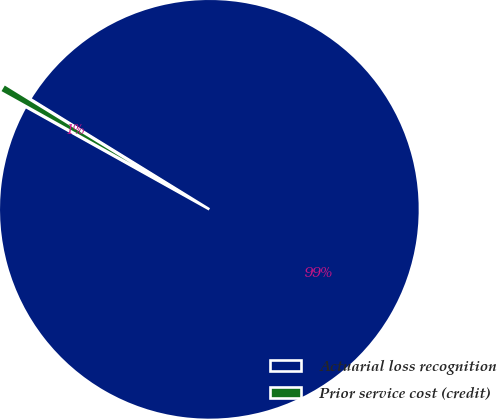Convert chart. <chart><loc_0><loc_0><loc_500><loc_500><pie_chart><fcel>Actuarial loss recognition<fcel>Prior service cost (credit)<nl><fcel>99.31%<fcel>0.69%<nl></chart> 